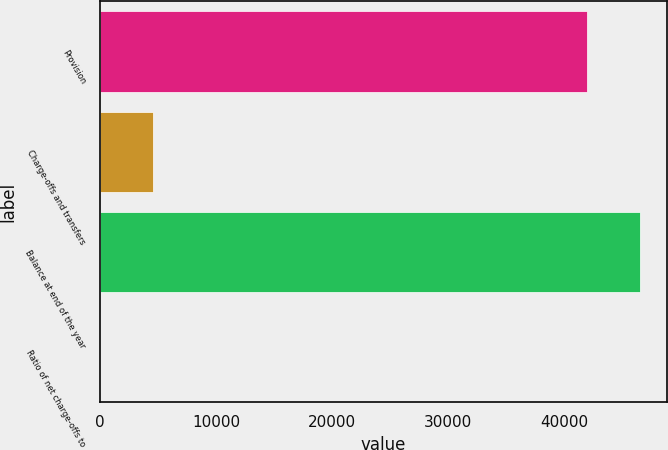<chart> <loc_0><loc_0><loc_500><loc_500><bar_chart><fcel>Provision<fcel>Charge-offs and transfers<fcel>Balance at end of the year<fcel>Ratio of net charge-offs to<nl><fcel>42004<fcel>4540.18<fcel>46544.1<fcel>0.09<nl></chart> 